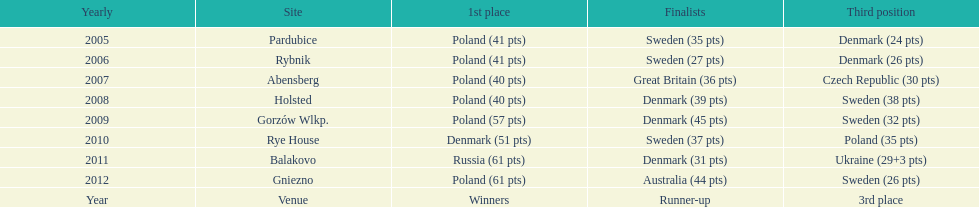What is the total number of points earned in the years 2009? 134. 